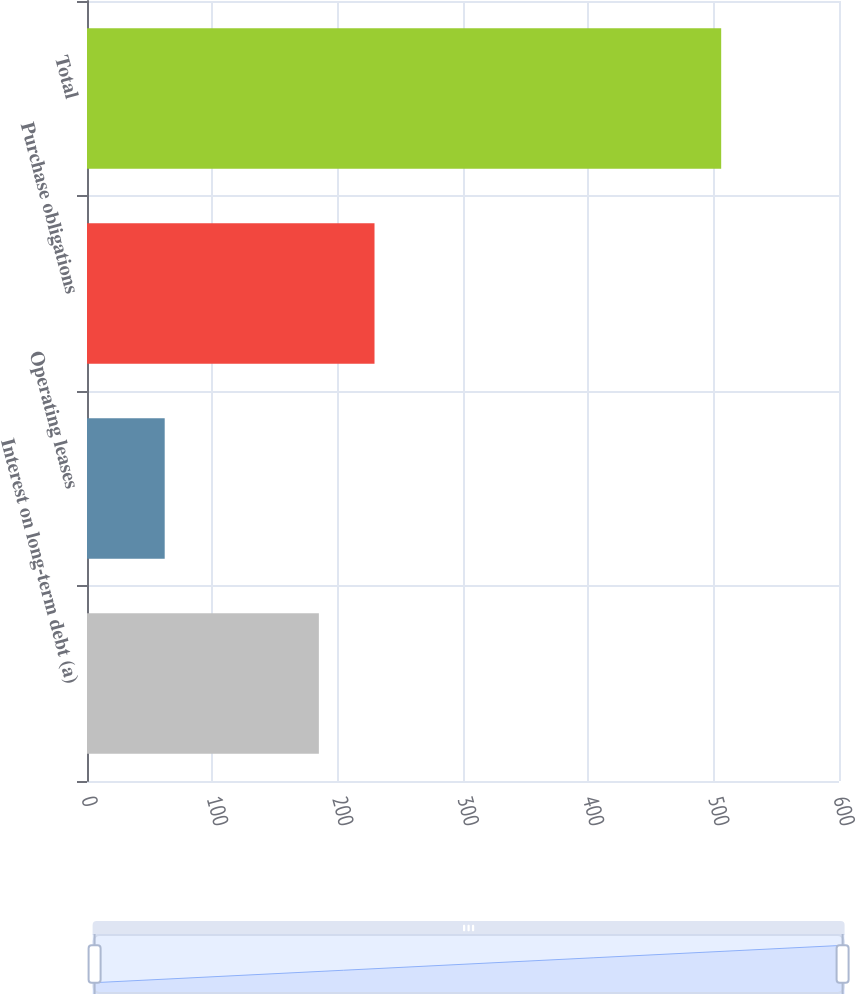Convert chart to OTSL. <chart><loc_0><loc_0><loc_500><loc_500><bar_chart><fcel>Interest on long-term debt (a)<fcel>Operating leases<fcel>Purchase obligations<fcel>Total<nl><fcel>185<fcel>62<fcel>229.4<fcel>506<nl></chart> 